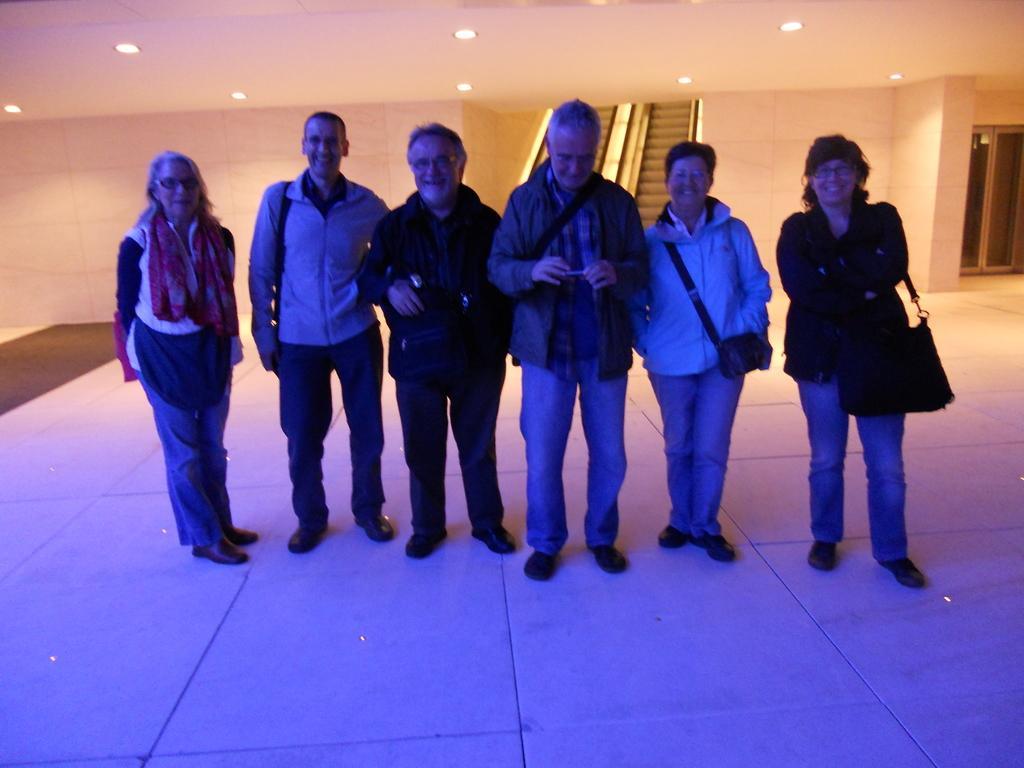In one or two sentences, can you explain what this image depicts? Here we can see six persons are standing on the floor and they are smiling. In the background we can see wall, door, and lights. 